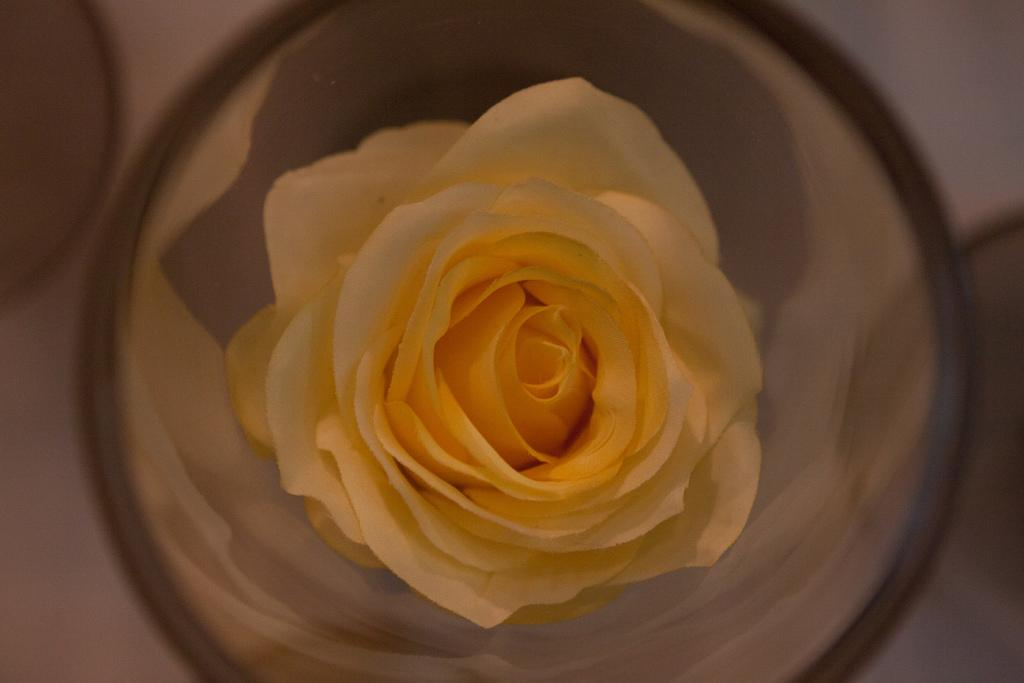What is the main subject of the image? There is a rose in a glass in the image. Where is the rose located in relation to the glass? The rose is in the center of the glass. What can be seen in the background of the image? There is a table in the background of the image. What else is on the table besides the rose in the glass? There are glasses on the table. What day of the week is it in the image? The day of the week is not mentioned or depicted in the image. 